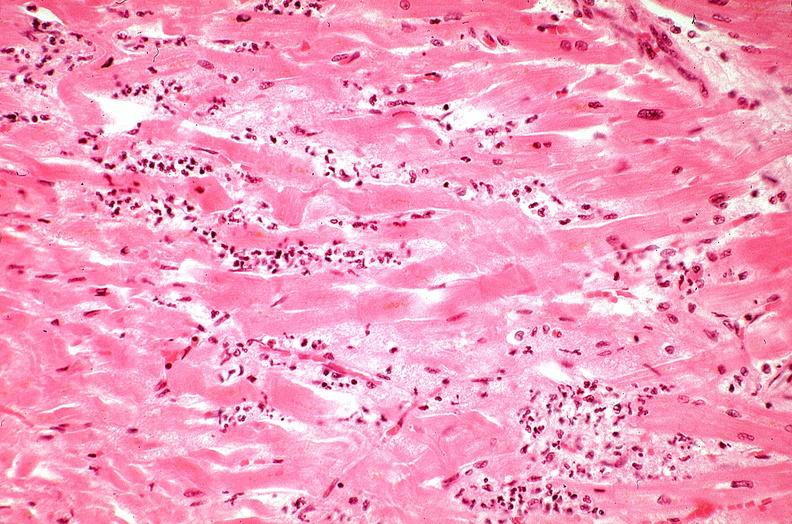what does this image show?
Answer the question using a single word or phrase. Heart 